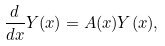<formula> <loc_0><loc_0><loc_500><loc_500>\frac { d } { d x } Y ( x ) = A ( x ) Y ( x ) ,</formula> 